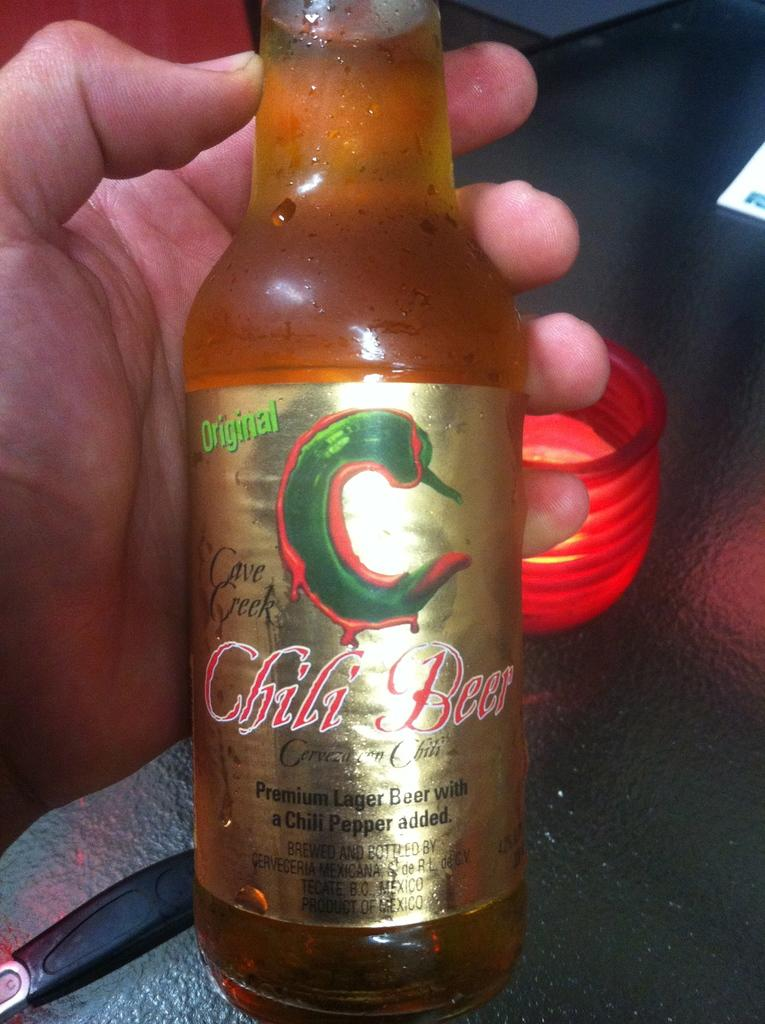<image>
Render a clear and concise summary of the photo. a bottle of original chili beer being held up by someone 